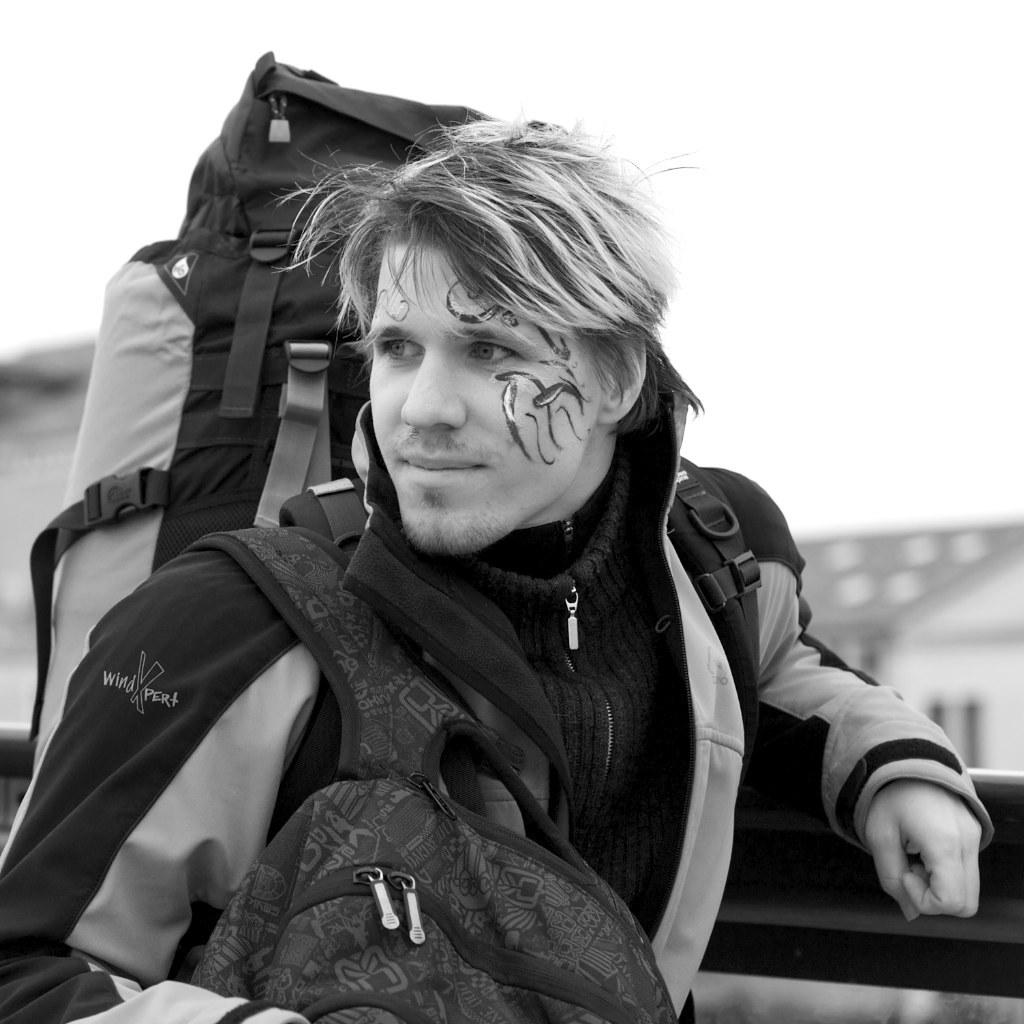What is the person wearing in the image? The person is wearing a black jacket. What is the person carrying in the image? The person is carrying two bags. Can you describe any unique features on the person's face? The person has a tattoo on their face. What type of wire is being used to pull the carriage in the image? There is no carriage or wire present in the image; it features a person wearing a black jacket and carrying two bags. 